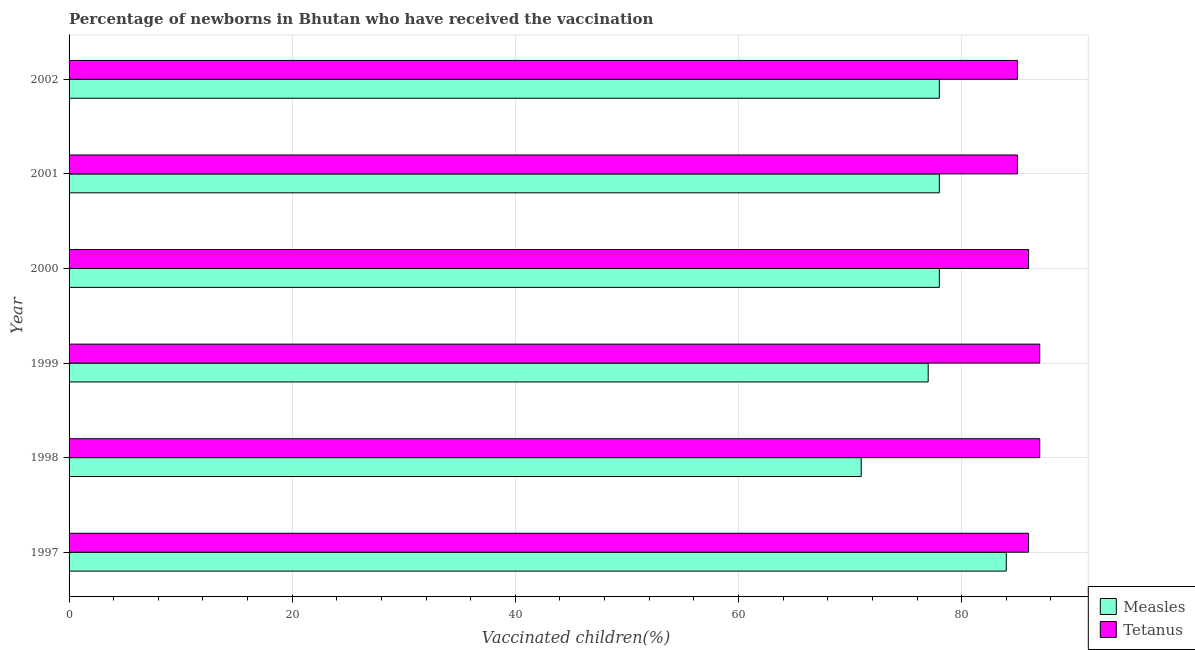How many different coloured bars are there?
Your answer should be very brief. 2. Are the number of bars on each tick of the Y-axis equal?
Offer a terse response. Yes. In how many cases, is the number of bars for a given year not equal to the number of legend labels?
Make the answer very short. 0. What is the percentage of newborns who received vaccination for tetanus in 2002?
Offer a very short reply. 85. Across all years, what is the maximum percentage of newborns who received vaccination for tetanus?
Make the answer very short. 87. Across all years, what is the minimum percentage of newborns who received vaccination for tetanus?
Provide a short and direct response. 85. In which year was the percentage of newborns who received vaccination for measles maximum?
Keep it short and to the point. 1997. In which year was the percentage of newborns who received vaccination for tetanus minimum?
Your answer should be very brief. 2001. What is the total percentage of newborns who received vaccination for tetanus in the graph?
Ensure brevity in your answer.  516. What is the difference between the percentage of newborns who received vaccination for measles in 2000 and the percentage of newborns who received vaccination for tetanus in 2002?
Offer a terse response. -7. What is the average percentage of newborns who received vaccination for measles per year?
Your answer should be very brief. 77.67. In the year 2000, what is the difference between the percentage of newborns who received vaccination for measles and percentage of newborns who received vaccination for tetanus?
Provide a succinct answer. -8. In how many years, is the percentage of newborns who received vaccination for measles greater than 16 %?
Make the answer very short. 6. What is the ratio of the percentage of newborns who received vaccination for tetanus in 1997 to that in 2001?
Offer a very short reply. 1.01. What is the difference between the highest and the second highest percentage of newborns who received vaccination for tetanus?
Offer a very short reply. 0. What is the difference between the highest and the lowest percentage of newborns who received vaccination for measles?
Provide a succinct answer. 13. Is the sum of the percentage of newborns who received vaccination for tetanus in 1998 and 2001 greater than the maximum percentage of newborns who received vaccination for measles across all years?
Provide a succinct answer. Yes. What does the 1st bar from the top in 2001 represents?
Your answer should be very brief. Tetanus. What does the 1st bar from the bottom in 2000 represents?
Offer a terse response. Measles. How many bars are there?
Keep it short and to the point. 12. How many years are there in the graph?
Offer a terse response. 6. Are the values on the major ticks of X-axis written in scientific E-notation?
Keep it short and to the point. No. Does the graph contain grids?
Offer a terse response. Yes. How many legend labels are there?
Your response must be concise. 2. What is the title of the graph?
Provide a succinct answer. Percentage of newborns in Bhutan who have received the vaccination. What is the label or title of the X-axis?
Your answer should be compact. Vaccinated children(%)
. What is the label or title of the Y-axis?
Make the answer very short. Year. What is the Vaccinated children(%)
 in Measles in 1998?
Offer a terse response. 71. What is the Vaccinated children(%)
 in Tetanus in 1999?
Your response must be concise. 87. What is the Vaccinated children(%)
 of Tetanus in 2001?
Your response must be concise. 85. Across all years, what is the minimum Vaccinated children(%)
 of Tetanus?
Offer a terse response. 85. What is the total Vaccinated children(%)
 in Measles in the graph?
Your answer should be compact. 466. What is the total Vaccinated children(%)
 in Tetanus in the graph?
Provide a succinct answer. 516. What is the difference between the Vaccinated children(%)
 of Measles in 1997 and that in 1998?
Offer a very short reply. 13. What is the difference between the Vaccinated children(%)
 in Tetanus in 1997 and that in 1999?
Your response must be concise. -1. What is the difference between the Vaccinated children(%)
 in Measles in 1997 and that in 2000?
Give a very brief answer. 6. What is the difference between the Vaccinated children(%)
 of Measles in 1997 and that in 2001?
Provide a succinct answer. 6. What is the difference between the Vaccinated children(%)
 in Tetanus in 1997 and that in 2002?
Provide a succinct answer. 1. What is the difference between the Vaccinated children(%)
 in Measles in 1998 and that in 1999?
Give a very brief answer. -6. What is the difference between the Vaccinated children(%)
 of Tetanus in 1998 and that in 1999?
Ensure brevity in your answer.  0. What is the difference between the Vaccinated children(%)
 of Measles in 1998 and that in 2001?
Give a very brief answer. -7. What is the difference between the Vaccinated children(%)
 of Tetanus in 1998 and that in 2001?
Provide a succinct answer. 2. What is the difference between the Vaccinated children(%)
 in Tetanus in 1999 and that in 2002?
Give a very brief answer. 2. What is the difference between the Vaccinated children(%)
 in Measles in 2000 and that in 2001?
Ensure brevity in your answer.  0. What is the difference between the Vaccinated children(%)
 in Tetanus in 2000 and that in 2001?
Give a very brief answer. 1. What is the difference between the Vaccinated children(%)
 of Measles in 2000 and that in 2002?
Your answer should be compact. 0. What is the difference between the Vaccinated children(%)
 of Tetanus in 2000 and that in 2002?
Offer a terse response. 1. What is the difference between the Vaccinated children(%)
 in Measles in 1997 and the Vaccinated children(%)
 in Tetanus in 1999?
Provide a short and direct response. -3. What is the difference between the Vaccinated children(%)
 of Measles in 1997 and the Vaccinated children(%)
 of Tetanus in 2002?
Your response must be concise. -1. What is the difference between the Vaccinated children(%)
 of Measles in 1998 and the Vaccinated children(%)
 of Tetanus in 1999?
Provide a succinct answer. -16. What is the difference between the Vaccinated children(%)
 in Measles in 1998 and the Vaccinated children(%)
 in Tetanus in 2001?
Ensure brevity in your answer.  -14. What is the difference between the Vaccinated children(%)
 in Measles in 1999 and the Vaccinated children(%)
 in Tetanus in 2000?
Provide a succinct answer. -9. What is the difference between the Vaccinated children(%)
 of Measles in 1999 and the Vaccinated children(%)
 of Tetanus in 2001?
Provide a succinct answer. -8. What is the difference between the Vaccinated children(%)
 of Measles in 2000 and the Vaccinated children(%)
 of Tetanus in 2001?
Keep it short and to the point. -7. What is the average Vaccinated children(%)
 in Measles per year?
Offer a very short reply. 77.67. In the year 1997, what is the difference between the Vaccinated children(%)
 of Measles and Vaccinated children(%)
 of Tetanus?
Keep it short and to the point. -2. In the year 1998, what is the difference between the Vaccinated children(%)
 of Measles and Vaccinated children(%)
 of Tetanus?
Provide a short and direct response. -16. In the year 2001, what is the difference between the Vaccinated children(%)
 of Measles and Vaccinated children(%)
 of Tetanus?
Keep it short and to the point. -7. What is the ratio of the Vaccinated children(%)
 in Measles in 1997 to that in 1998?
Make the answer very short. 1.18. What is the ratio of the Vaccinated children(%)
 of Tetanus in 1997 to that in 1999?
Keep it short and to the point. 0.99. What is the ratio of the Vaccinated children(%)
 of Measles in 1997 to that in 2000?
Ensure brevity in your answer.  1.08. What is the ratio of the Vaccinated children(%)
 in Measles in 1997 to that in 2001?
Keep it short and to the point. 1.08. What is the ratio of the Vaccinated children(%)
 of Tetanus in 1997 to that in 2001?
Your answer should be compact. 1.01. What is the ratio of the Vaccinated children(%)
 in Measles in 1997 to that in 2002?
Give a very brief answer. 1.08. What is the ratio of the Vaccinated children(%)
 in Tetanus in 1997 to that in 2002?
Your response must be concise. 1.01. What is the ratio of the Vaccinated children(%)
 in Measles in 1998 to that in 1999?
Provide a short and direct response. 0.92. What is the ratio of the Vaccinated children(%)
 in Tetanus in 1998 to that in 1999?
Make the answer very short. 1. What is the ratio of the Vaccinated children(%)
 of Measles in 1998 to that in 2000?
Offer a very short reply. 0.91. What is the ratio of the Vaccinated children(%)
 of Tetanus in 1998 to that in 2000?
Your response must be concise. 1.01. What is the ratio of the Vaccinated children(%)
 in Measles in 1998 to that in 2001?
Make the answer very short. 0.91. What is the ratio of the Vaccinated children(%)
 in Tetanus in 1998 to that in 2001?
Give a very brief answer. 1.02. What is the ratio of the Vaccinated children(%)
 of Measles in 1998 to that in 2002?
Provide a short and direct response. 0.91. What is the ratio of the Vaccinated children(%)
 of Tetanus in 1998 to that in 2002?
Provide a succinct answer. 1.02. What is the ratio of the Vaccinated children(%)
 of Measles in 1999 to that in 2000?
Ensure brevity in your answer.  0.99. What is the ratio of the Vaccinated children(%)
 of Tetanus in 1999 to that in 2000?
Your response must be concise. 1.01. What is the ratio of the Vaccinated children(%)
 of Measles in 1999 to that in 2001?
Ensure brevity in your answer.  0.99. What is the ratio of the Vaccinated children(%)
 of Tetanus in 1999 to that in 2001?
Provide a succinct answer. 1.02. What is the ratio of the Vaccinated children(%)
 of Measles in 1999 to that in 2002?
Keep it short and to the point. 0.99. What is the ratio of the Vaccinated children(%)
 in Tetanus in 1999 to that in 2002?
Offer a terse response. 1.02. What is the ratio of the Vaccinated children(%)
 in Tetanus in 2000 to that in 2001?
Provide a short and direct response. 1.01. What is the ratio of the Vaccinated children(%)
 of Tetanus in 2000 to that in 2002?
Your answer should be very brief. 1.01. What is the ratio of the Vaccinated children(%)
 of Measles in 2001 to that in 2002?
Ensure brevity in your answer.  1. What is the ratio of the Vaccinated children(%)
 of Tetanus in 2001 to that in 2002?
Offer a very short reply. 1. What is the difference between the highest and the second highest Vaccinated children(%)
 in Measles?
Provide a succinct answer. 6. What is the difference between the highest and the second highest Vaccinated children(%)
 in Tetanus?
Provide a succinct answer. 0. What is the difference between the highest and the lowest Vaccinated children(%)
 in Measles?
Offer a terse response. 13. What is the difference between the highest and the lowest Vaccinated children(%)
 of Tetanus?
Your response must be concise. 2. 